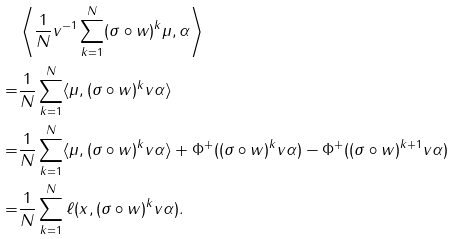Convert formula to latex. <formula><loc_0><loc_0><loc_500><loc_500>& \left \langle \frac { 1 } { N } v ^ { - 1 } \sum _ { k = 1 } ^ { N } ( \sigma \circ w ) ^ { k } \mu , \alpha \right \rangle \\ = & \frac { 1 } { N } \sum _ { k = 1 } ^ { N } \langle \mu , ( \sigma \circ w ) ^ { k } v \alpha \rangle \\ = & \frac { 1 } { N } \sum _ { k = 1 } ^ { N } \langle \mu , ( \sigma \circ w ) ^ { k } v \alpha \rangle + \Phi ^ { + } ( ( \sigma \circ w ) ^ { k } v \alpha ) - \Phi ^ { + } ( ( \sigma \circ w ) ^ { k + 1 } v \alpha ) \\ = & \frac { 1 } { N } \sum _ { k = 1 } ^ { N } \ell ( x , ( \sigma \circ w ) ^ { k } v \alpha ) .</formula> 